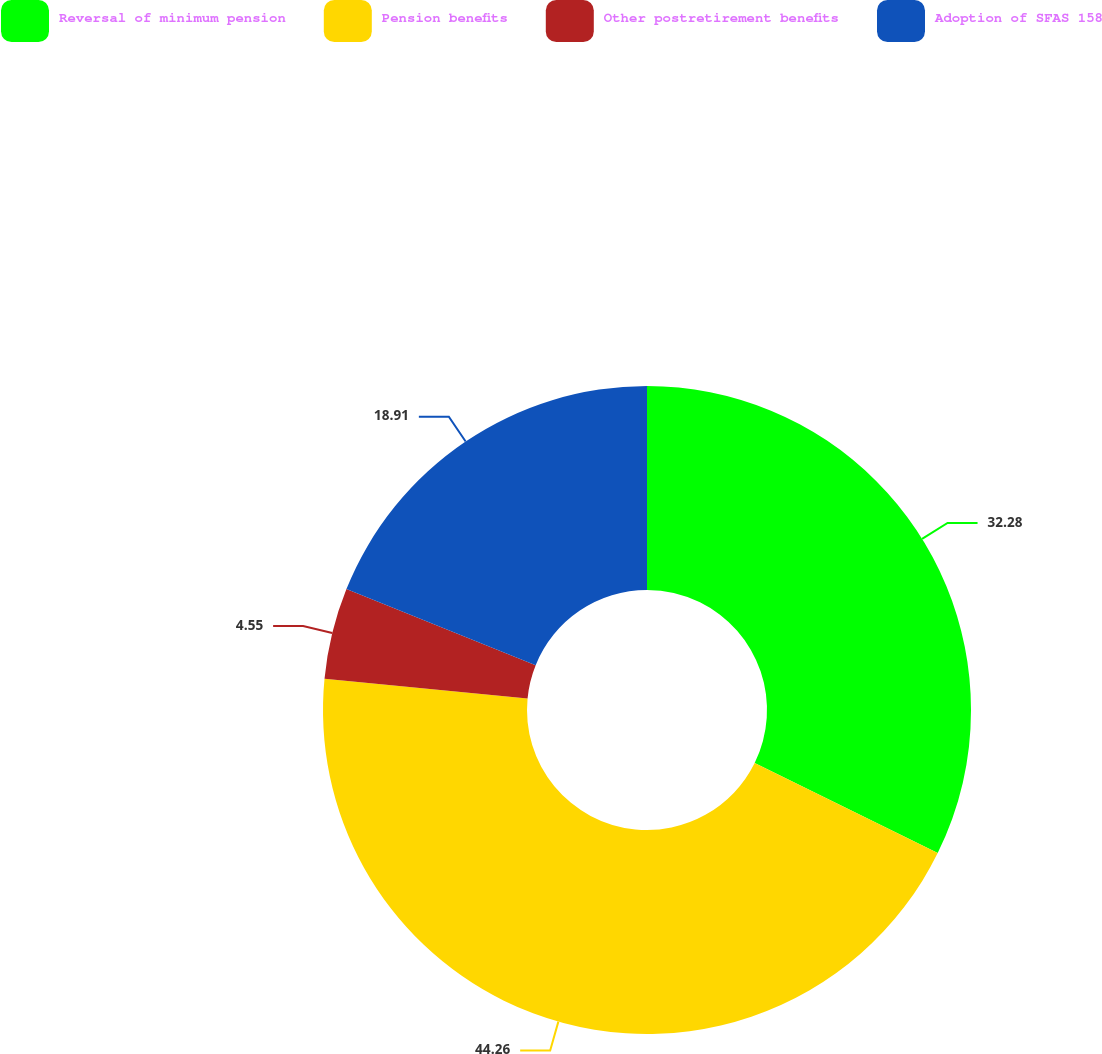Convert chart to OTSL. <chart><loc_0><loc_0><loc_500><loc_500><pie_chart><fcel>Reversal of minimum pension<fcel>Pension benefits<fcel>Other postretirement benefits<fcel>Adoption of SFAS 158<nl><fcel>32.28%<fcel>44.26%<fcel>4.55%<fcel>18.91%<nl></chart> 